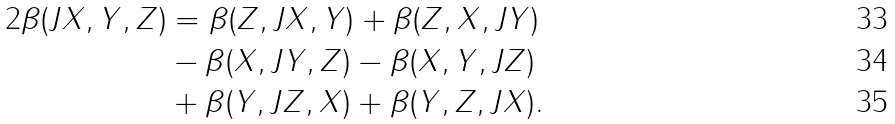Convert formula to latex. <formula><loc_0><loc_0><loc_500><loc_500>2 \beta ( J X , Y , Z ) & = \beta ( Z , J X , Y ) + \beta ( Z , X , J Y ) \\ & - \beta ( X , J Y , Z ) - \beta ( X , Y , J Z ) \\ & + \beta ( Y , J Z , X ) + \beta ( Y , Z , J X ) .</formula> 